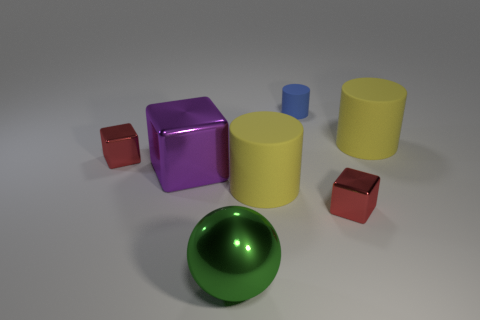Is the number of purple metal cubes that are behind the tiny blue object less than the number of large brown rubber balls?
Your answer should be compact. No. Is the color of the large metal sphere the same as the small rubber cylinder?
Offer a terse response. No. How many tiny red things are made of the same material as the big sphere?
Ensure brevity in your answer.  2. Does the red block in front of the large purple metal object have the same material as the big green sphere?
Your response must be concise. Yes. Are there the same number of red metallic objects that are behind the small blue matte thing and blocks?
Ensure brevity in your answer.  No. The purple thing is what size?
Keep it short and to the point. Large. Is the green metal sphere the same size as the purple cube?
Your response must be concise. Yes. There is a yellow rubber object that is behind the small red object that is left of the small matte cylinder; what is its size?
Keep it short and to the point. Large. Do the big metal cube and the big matte cylinder that is to the left of the blue thing have the same color?
Provide a short and direct response. No. Is there a yellow thing of the same size as the metal ball?
Keep it short and to the point. Yes. 